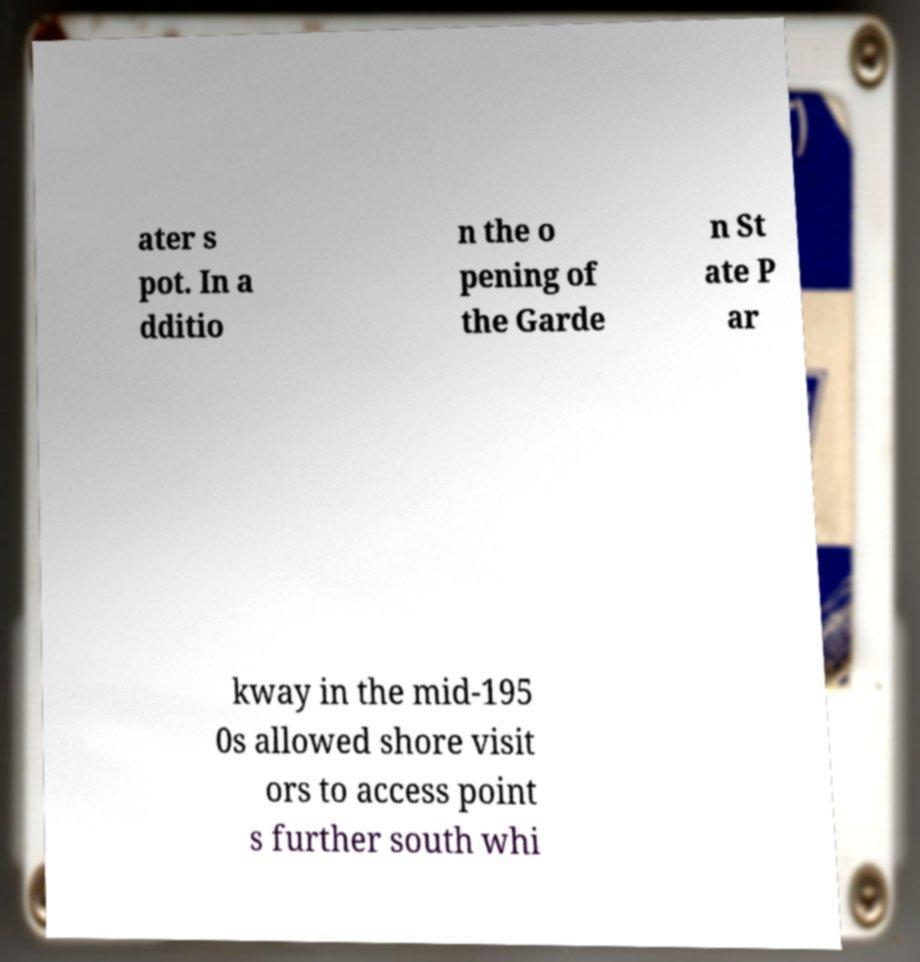Please identify and transcribe the text found in this image. ater s pot. In a dditio n the o pening of the Garde n St ate P ar kway in the mid-195 0s allowed shore visit ors to access point s further south whi 